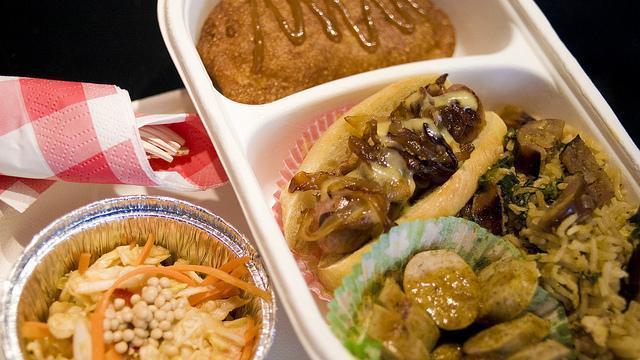How many bowls are there?
Give a very brief answer. 2. How many black railroad cars are at the train station?
Give a very brief answer. 0. 